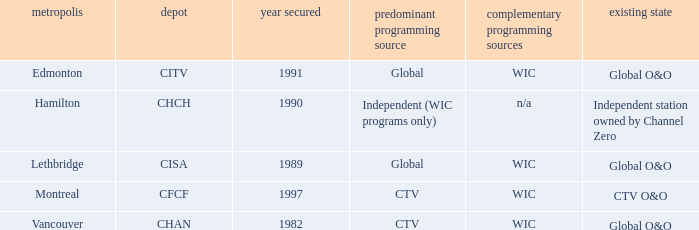How many is the minimum for citv 1991.0. 